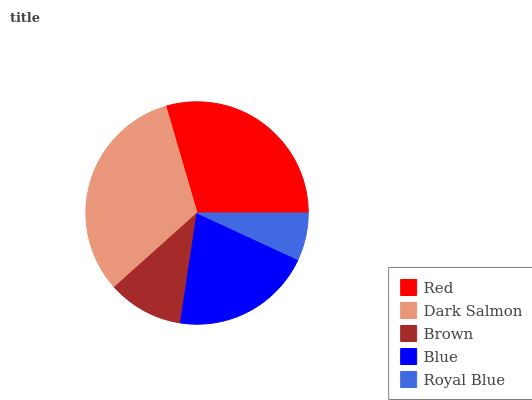Is Royal Blue the minimum?
Answer yes or no. Yes. Is Dark Salmon the maximum?
Answer yes or no. Yes. Is Brown the minimum?
Answer yes or no. No. Is Brown the maximum?
Answer yes or no. No. Is Dark Salmon greater than Brown?
Answer yes or no. Yes. Is Brown less than Dark Salmon?
Answer yes or no. Yes. Is Brown greater than Dark Salmon?
Answer yes or no. No. Is Dark Salmon less than Brown?
Answer yes or no. No. Is Blue the high median?
Answer yes or no. Yes. Is Blue the low median?
Answer yes or no. Yes. Is Red the high median?
Answer yes or no. No. Is Red the low median?
Answer yes or no. No. 